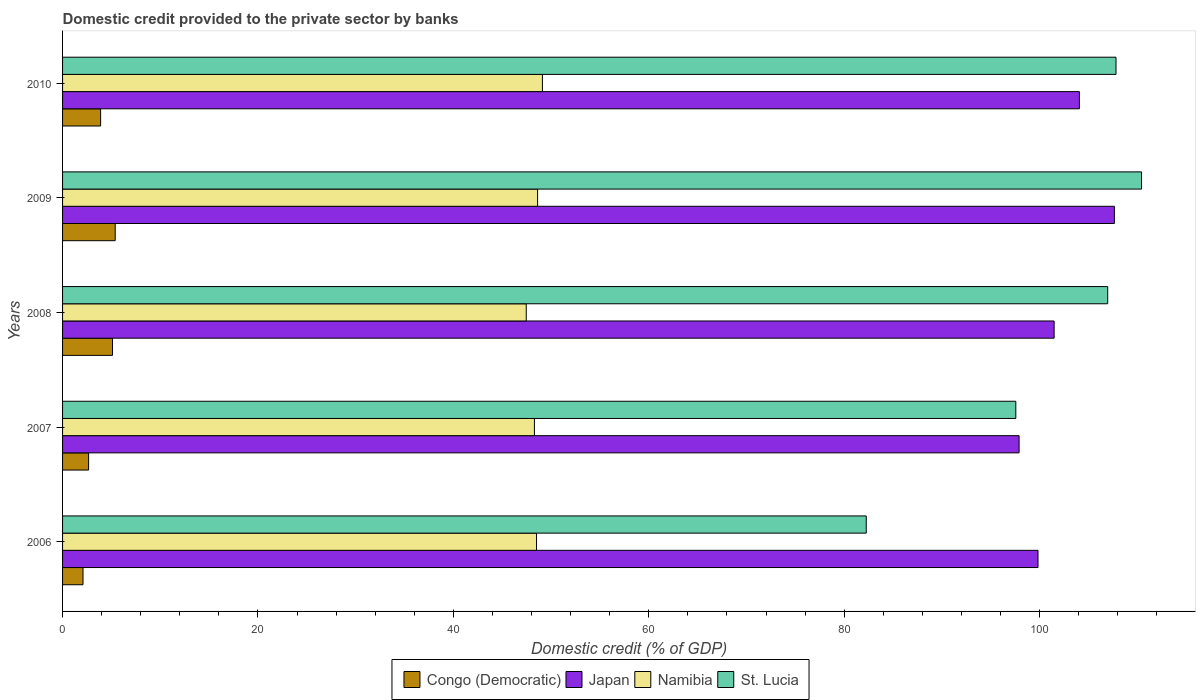How many different coloured bars are there?
Your answer should be very brief. 4. Are the number of bars per tick equal to the number of legend labels?
Ensure brevity in your answer.  Yes. Are the number of bars on each tick of the Y-axis equal?
Your answer should be very brief. Yes. How many bars are there on the 4th tick from the top?
Make the answer very short. 4. What is the label of the 2nd group of bars from the top?
Your response must be concise. 2009. In how many cases, is the number of bars for a given year not equal to the number of legend labels?
Provide a short and direct response. 0. What is the domestic credit provided to the private sector by banks in Japan in 2009?
Your answer should be compact. 107.65. Across all years, what is the maximum domestic credit provided to the private sector by banks in Japan?
Offer a very short reply. 107.65. Across all years, what is the minimum domestic credit provided to the private sector by banks in Namibia?
Your response must be concise. 47.46. In which year was the domestic credit provided to the private sector by banks in Japan minimum?
Your response must be concise. 2007. What is the total domestic credit provided to the private sector by banks in St. Lucia in the graph?
Provide a succinct answer. 505.04. What is the difference between the domestic credit provided to the private sector by banks in Congo (Democratic) in 2006 and that in 2010?
Your answer should be compact. -1.8. What is the difference between the domestic credit provided to the private sector by banks in Congo (Democratic) in 2009 and the domestic credit provided to the private sector by banks in Namibia in 2007?
Provide a succinct answer. -42.91. What is the average domestic credit provided to the private sector by banks in Japan per year?
Give a very brief answer. 102.19. In the year 2008, what is the difference between the domestic credit provided to the private sector by banks in St. Lucia and domestic credit provided to the private sector by banks in Japan?
Make the answer very short. 5.48. What is the ratio of the domestic credit provided to the private sector by banks in Congo (Democratic) in 2006 to that in 2009?
Your response must be concise. 0.39. Is the domestic credit provided to the private sector by banks in Congo (Democratic) in 2009 less than that in 2010?
Offer a very short reply. No. Is the difference between the domestic credit provided to the private sector by banks in St. Lucia in 2008 and 2009 greater than the difference between the domestic credit provided to the private sector by banks in Japan in 2008 and 2009?
Ensure brevity in your answer.  Yes. What is the difference between the highest and the second highest domestic credit provided to the private sector by banks in St. Lucia?
Ensure brevity in your answer.  2.61. What is the difference between the highest and the lowest domestic credit provided to the private sector by banks in Congo (Democratic)?
Keep it short and to the point. 3.3. What does the 2nd bar from the top in 2010 represents?
Ensure brevity in your answer.  Namibia. What does the 4th bar from the bottom in 2006 represents?
Offer a terse response. St. Lucia. How many bars are there?
Provide a succinct answer. 20. Are the values on the major ticks of X-axis written in scientific E-notation?
Offer a terse response. No. What is the title of the graph?
Your answer should be compact. Domestic credit provided to the private sector by banks. What is the label or title of the X-axis?
Provide a short and direct response. Domestic credit (% of GDP). What is the label or title of the Y-axis?
Keep it short and to the point. Years. What is the Domestic credit (% of GDP) in Congo (Democratic) in 2006?
Your answer should be compact. 2.09. What is the Domestic credit (% of GDP) of Japan in 2006?
Ensure brevity in your answer.  99.84. What is the Domestic credit (% of GDP) of Namibia in 2006?
Keep it short and to the point. 48.51. What is the Domestic credit (% of GDP) of St. Lucia in 2006?
Offer a terse response. 82.26. What is the Domestic credit (% of GDP) of Congo (Democratic) in 2007?
Provide a succinct answer. 2.67. What is the Domestic credit (% of GDP) in Japan in 2007?
Make the answer very short. 97.9. What is the Domestic credit (% of GDP) in Namibia in 2007?
Offer a terse response. 48.29. What is the Domestic credit (% of GDP) of St. Lucia in 2007?
Offer a very short reply. 97.56. What is the Domestic credit (% of GDP) in Congo (Democratic) in 2008?
Offer a very short reply. 5.11. What is the Domestic credit (% of GDP) of Japan in 2008?
Provide a short and direct response. 101.48. What is the Domestic credit (% of GDP) of Namibia in 2008?
Keep it short and to the point. 47.46. What is the Domestic credit (% of GDP) in St. Lucia in 2008?
Your response must be concise. 106.97. What is the Domestic credit (% of GDP) in Congo (Democratic) in 2009?
Give a very brief answer. 5.39. What is the Domestic credit (% of GDP) of Japan in 2009?
Make the answer very short. 107.65. What is the Domestic credit (% of GDP) in Namibia in 2009?
Ensure brevity in your answer.  48.62. What is the Domestic credit (% of GDP) in St. Lucia in 2009?
Offer a terse response. 110.43. What is the Domestic credit (% of GDP) of Congo (Democratic) in 2010?
Ensure brevity in your answer.  3.89. What is the Domestic credit (% of GDP) of Japan in 2010?
Your response must be concise. 104.07. What is the Domestic credit (% of GDP) of Namibia in 2010?
Offer a terse response. 49.11. What is the Domestic credit (% of GDP) of St. Lucia in 2010?
Offer a very short reply. 107.82. Across all years, what is the maximum Domestic credit (% of GDP) of Congo (Democratic)?
Provide a succinct answer. 5.39. Across all years, what is the maximum Domestic credit (% of GDP) of Japan?
Keep it short and to the point. 107.65. Across all years, what is the maximum Domestic credit (% of GDP) in Namibia?
Keep it short and to the point. 49.11. Across all years, what is the maximum Domestic credit (% of GDP) in St. Lucia?
Give a very brief answer. 110.43. Across all years, what is the minimum Domestic credit (% of GDP) in Congo (Democratic)?
Your response must be concise. 2.09. Across all years, what is the minimum Domestic credit (% of GDP) of Japan?
Keep it short and to the point. 97.9. Across all years, what is the minimum Domestic credit (% of GDP) of Namibia?
Provide a succinct answer. 47.46. Across all years, what is the minimum Domestic credit (% of GDP) of St. Lucia?
Provide a short and direct response. 82.26. What is the total Domestic credit (% of GDP) in Congo (Democratic) in the graph?
Your answer should be compact. 19.15. What is the total Domestic credit (% of GDP) in Japan in the graph?
Provide a short and direct response. 510.94. What is the total Domestic credit (% of GDP) of Namibia in the graph?
Ensure brevity in your answer.  241.99. What is the total Domestic credit (% of GDP) of St. Lucia in the graph?
Provide a short and direct response. 505.04. What is the difference between the Domestic credit (% of GDP) in Congo (Democratic) in 2006 and that in 2007?
Provide a short and direct response. -0.57. What is the difference between the Domestic credit (% of GDP) of Japan in 2006 and that in 2007?
Keep it short and to the point. 1.94. What is the difference between the Domestic credit (% of GDP) in Namibia in 2006 and that in 2007?
Your response must be concise. 0.22. What is the difference between the Domestic credit (% of GDP) of St. Lucia in 2006 and that in 2007?
Provide a short and direct response. -15.31. What is the difference between the Domestic credit (% of GDP) of Congo (Democratic) in 2006 and that in 2008?
Your answer should be compact. -3.02. What is the difference between the Domestic credit (% of GDP) of Japan in 2006 and that in 2008?
Provide a short and direct response. -1.65. What is the difference between the Domestic credit (% of GDP) of Namibia in 2006 and that in 2008?
Your answer should be very brief. 1.05. What is the difference between the Domestic credit (% of GDP) of St. Lucia in 2006 and that in 2008?
Your answer should be very brief. -24.71. What is the difference between the Domestic credit (% of GDP) in Congo (Democratic) in 2006 and that in 2009?
Provide a succinct answer. -3.3. What is the difference between the Domestic credit (% of GDP) of Japan in 2006 and that in 2009?
Make the answer very short. -7.82. What is the difference between the Domestic credit (% of GDP) in Namibia in 2006 and that in 2009?
Ensure brevity in your answer.  -0.11. What is the difference between the Domestic credit (% of GDP) in St. Lucia in 2006 and that in 2009?
Ensure brevity in your answer.  -28.18. What is the difference between the Domestic credit (% of GDP) of Congo (Democratic) in 2006 and that in 2010?
Offer a terse response. -1.8. What is the difference between the Domestic credit (% of GDP) in Japan in 2006 and that in 2010?
Your answer should be very brief. -4.24. What is the difference between the Domestic credit (% of GDP) of Namibia in 2006 and that in 2010?
Your answer should be compact. -0.6. What is the difference between the Domestic credit (% of GDP) of St. Lucia in 2006 and that in 2010?
Your answer should be very brief. -25.56. What is the difference between the Domestic credit (% of GDP) in Congo (Democratic) in 2007 and that in 2008?
Your response must be concise. -2.45. What is the difference between the Domestic credit (% of GDP) in Japan in 2007 and that in 2008?
Provide a succinct answer. -3.59. What is the difference between the Domestic credit (% of GDP) of Namibia in 2007 and that in 2008?
Provide a succinct answer. 0.84. What is the difference between the Domestic credit (% of GDP) in St. Lucia in 2007 and that in 2008?
Ensure brevity in your answer.  -9.41. What is the difference between the Domestic credit (% of GDP) in Congo (Democratic) in 2007 and that in 2009?
Give a very brief answer. -2.72. What is the difference between the Domestic credit (% of GDP) in Japan in 2007 and that in 2009?
Provide a succinct answer. -9.75. What is the difference between the Domestic credit (% of GDP) in Namibia in 2007 and that in 2009?
Provide a succinct answer. -0.32. What is the difference between the Domestic credit (% of GDP) of St. Lucia in 2007 and that in 2009?
Offer a very short reply. -12.87. What is the difference between the Domestic credit (% of GDP) of Congo (Democratic) in 2007 and that in 2010?
Your answer should be very brief. -1.23. What is the difference between the Domestic credit (% of GDP) in Japan in 2007 and that in 2010?
Provide a succinct answer. -6.17. What is the difference between the Domestic credit (% of GDP) in Namibia in 2007 and that in 2010?
Offer a terse response. -0.82. What is the difference between the Domestic credit (% of GDP) in St. Lucia in 2007 and that in 2010?
Provide a succinct answer. -10.26. What is the difference between the Domestic credit (% of GDP) of Congo (Democratic) in 2008 and that in 2009?
Your answer should be compact. -0.28. What is the difference between the Domestic credit (% of GDP) in Japan in 2008 and that in 2009?
Your response must be concise. -6.17. What is the difference between the Domestic credit (% of GDP) in Namibia in 2008 and that in 2009?
Give a very brief answer. -1.16. What is the difference between the Domestic credit (% of GDP) in St. Lucia in 2008 and that in 2009?
Give a very brief answer. -3.46. What is the difference between the Domestic credit (% of GDP) of Congo (Democratic) in 2008 and that in 2010?
Your answer should be very brief. 1.22. What is the difference between the Domestic credit (% of GDP) in Japan in 2008 and that in 2010?
Give a very brief answer. -2.59. What is the difference between the Domestic credit (% of GDP) of Namibia in 2008 and that in 2010?
Provide a succinct answer. -1.65. What is the difference between the Domestic credit (% of GDP) of St. Lucia in 2008 and that in 2010?
Make the answer very short. -0.85. What is the difference between the Domestic credit (% of GDP) of Congo (Democratic) in 2009 and that in 2010?
Ensure brevity in your answer.  1.49. What is the difference between the Domestic credit (% of GDP) of Japan in 2009 and that in 2010?
Offer a very short reply. 3.58. What is the difference between the Domestic credit (% of GDP) of Namibia in 2009 and that in 2010?
Keep it short and to the point. -0.49. What is the difference between the Domestic credit (% of GDP) in St. Lucia in 2009 and that in 2010?
Provide a succinct answer. 2.61. What is the difference between the Domestic credit (% of GDP) in Congo (Democratic) in 2006 and the Domestic credit (% of GDP) in Japan in 2007?
Make the answer very short. -95.81. What is the difference between the Domestic credit (% of GDP) in Congo (Democratic) in 2006 and the Domestic credit (% of GDP) in Namibia in 2007?
Keep it short and to the point. -46.2. What is the difference between the Domestic credit (% of GDP) in Congo (Democratic) in 2006 and the Domestic credit (% of GDP) in St. Lucia in 2007?
Offer a terse response. -95.47. What is the difference between the Domestic credit (% of GDP) of Japan in 2006 and the Domestic credit (% of GDP) of Namibia in 2007?
Offer a terse response. 51.54. What is the difference between the Domestic credit (% of GDP) of Japan in 2006 and the Domestic credit (% of GDP) of St. Lucia in 2007?
Offer a very short reply. 2.27. What is the difference between the Domestic credit (% of GDP) in Namibia in 2006 and the Domestic credit (% of GDP) in St. Lucia in 2007?
Ensure brevity in your answer.  -49.05. What is the difference between the Domestic credit (% of GDP) in Congo (Democratic) in 2006 and the Domestic credit (% of GDP) in Japan in 2008?
Provide a succinct answer. -99.39. What is the difference between the Domestic credit (% of GDP) of Congo (Democratic) in 2006 and the Domestic credit (% of GDP) of Namibia in 2008?
Your answer should be very brief. -45.36. What is the difference between the Domestic credit (% of GDP) of Congo (Democratic) in 2006 and the Domestic credit (% of GDP) of St. Lucia in 2008?
Provide a short and direct response. -104.88. What is the difference between the Domestic credit (% of GDP) in Japan in 2006 and the Domestic credit (% of GDP) in Namibia in 2008?
Keep it short and to the point. 52.38. What is the difference between the Domestic credit (% of GDP) in Japan in 2006 and the Domestic credit (% of GDP) in St. Lucia in 2008?
Keep it short and to the point. -7.13. What is the difference between the Domestic credit (% of GDP) in Namibia in 2006 and the Domestic credit (% of GDP) in St. Lucia in 2008?
Give a very brief answer. -58.46. What is the difference between the Domestic credit (% of GDP) of Congo (Democratic) in 2006 and the Domestic credit (% of GDP) of Japan in 2009?
Give a very brief answer. -105.56. What is the difference between the Domestic credit (% of GDP) in Congo (Democratic) in 2006 and the Domestic credit (% of GDP) in Namibia in 2009?
Provide a succinct answer. -46.53. What is the difference between the Domestic credit (% of GDP) in Congo (Democratic) in 2006 and the Domestic credit (% of GDP) in St. Lucia in 2009?
Your response must be concise. -108.34. What is the difference between the Domestic credit (% of GDP) of Japan in 2006 and the Domestic credit (% of GDP) of Namibia in 2009?
Ensure brevity in your answer.  51.22. What is the difference between the Domestic credit (% of GDP) in Japan in 2006 and the Domestic credit (% of GDP) in St. Lucia in 2009?
Your answer should be very brief. -10.6. What is the difference between the Domestic credit (% of GDP) of Namibia in 2006 and the Domestic credit (% of GDP) of St. Lucia in 2009?
Give a very brief answer. -61.92. What is the difference between the Domestic credit (% of GDP) of Congo (Democratic) in 2006 and the Domestic credit (% of GDP) of Japan in 2010?
Offer a very short reply. -101.98. What is the difference between the Domestic credit (% of GDP) in Congo (Democratic) in 2006 and the Domestic credit (% of GDP) in Namibia in 2010?
Offer a very short reply. -47.02. What is the difference between the Domestic credit (% of GDP) in Congo (Democratic) in 2006 and the Domestic credit (% of GDP) in St. Lucia in 2010?
Offer a very short reply. -105.73. What is the difference between the Domestic credit (% of GDP) of Japan in 2006 and the Domestic credit (% of GDP) of Namibia in 2010?
Offer a terse response. 50.72. What is the difference between the Domestic credit (% of GDP) of Japan in 2006 and the Domestic credit (% of GDP) of St. Lucia in 2010?
Make the answer very short. -7.98. What is the difference between the Domestic credit (% of GDP) in Namibia in 2006 and the Domestic credit (% of GDP) in St. Lucia in 2010?
Make the answer very short. -59.31. What is the difference between the Domestic credit (% of GDP) of Congo (Democratic) in 2007 and the Domestic credit (% of GDP) of Japan in 2008?
Offer a terse response. -98.82. What is the difference between the Domestic credit (% of GDP) in Congo (Democratic) in 2007 and the Domestic credit (% of GDP) in Namibia in 2008?
Offer a very short reply. -44.79. What is the difference between the Domestic credit (% of GDP) in Congo (Democratic) in 2007 and the Domestic credit (% of GDP) in St. Lucia in 2008?
Keep it short and to the point. -104.3. What is the difference between the Domestic credit (% of GDP) in Japan in 2007 and the Domestic credit (% of GDP) in Namibia in 2008?
Your answer should be very brief. 50.44. What is the difference between the Domestic credit (% of GDP) in Japan in 2007 and the Domestic credit (% of GDP) in St. Lucia in 2008?
Provide a succinct answer. -9.07. What is the difference between the Domestic credit (% of GDP) in Namibia in 2007 and the Domestic credit (% of GDP) in St. Lucia in 2008?
Your answer should be very brief. -58.67. What is the difference between the Domestic credit (% of GDP) of Congo (Democratic) in 2007 and the Domestic credit (% of GDP) of Japan in 2009?
Keep it short and to the point. -104.98. What is the difference between the Domestic credit (% of GDP) of Congo (Democratic) in 2007 and the Domestic credit (% of GDP) of Namibia in 2009?
Your answer should be very brief. -45.95. What is the difference between the Domestic credit (% of GDP) in Congo (Democratic) in 2007 and the Domestic credit (% of GDP) in St. Lucia in 2009?
Ensure brevity in your answer.  -107.77. What is the difference between the Domestic credit (% of GDP) in Japan in 2007 and the Domestic credit (% of GDP) in Namibia in 2009?
Give a very brief answer. 49.28. What is the difference between the Domestic credit (% of GDP) in Japan in 2007 and the Domestic credit (% of GDP) in St. Lucia in 2009?
Your answer should be very brief. -12.53. What is the difference between the Domestic credit (% of GDP) in Namibia in 2007 and the Domestic credit (% of GDP) in St. Lucia in 2009?
Your answer should be very brief. -62.14. What is the difference between the Domestic credit (% of GDP) of Congo (Democratic) in 2007 and the Domestic credit (% of GDP) of Japan in 2010?
Make the answer very short. -101.41. What is the difference between the Domestic credit (% of GDP) of Congo (Democratic) in 2007 and the Domestic credit (% of GDP) of Namibia in 2010?
Your answer should be compact. -46.45. What is the difference between the Domestic credit (% of GDP) in Congo (Democratic) in 2007 and the Domestic credit (% of GDP) in St. Lucia in 2010?
Provide a short and direct response. -105.15. What is the difference between the Domestic credit (% of GDP) in Japan in 2007 and the Domestic credit (% of GDP) in Namibia in 2010?
Offer a very short reply. 48.79. What is the difference between the Domestic credit (% of GDP) of Japan in 2007 and the Domestic credit (% of GDP) of St. Lucia in 2010?
Provide a short and direct response. -9.92. What is the difference between the Domestic credit (% of GDP) in Namibia in 2007 and the Domestic credit (% of GDP) in St. Lucia in 2010?
Give a very brief answer. -59.52. What is the difference between the Domestic credit (% of GDP) of Congo (Democratic) in 2008 and the Domestic credit (% of GDP) of Japan in 2009?
Give a very brief answer. -102.54. What is the difference between the Domestic credit (% of GDP) of Congo (Democratic) in 2008 and the Domestic credit (% of GDP) of Namibia in 2009?
Make the answer very short. -43.51. What is the difference between the Domestic credit (% of GDP) of Congo (Democratic) in 2008 and the Domestic credit (% of GDP) of St. Lucia in 2009?
Offer a terse response. -105.32. What is the difference between the Domestic credit (% of GDP) of Japan in 2008 and the Domestic credit (% of GDP) of Namibia in 2009?
Offer a very short reply. 52.87. What is the difference between the Domestic credit (% of GDP) of Japan in 2008 and the Domestic credit (% of GDP) of St. Lucia in 2009?
Ensure brevity in your answer.  -8.95. What is the difference between the Domestic credit (% of GDP) of Namibia in 2008 and the Domestic credit (% of GDP) of St. Lucia in 2009?
Offer a very short reply. -62.97. What is the difference between the Domestic credit (% of GDP) of Congo (Democratic) in 2008 and the Domestic credit (% of GDP) of Japan in 2010?
Ensure brevity in your answer.  -98.96. What is the difference between the Domestic credit (% of GDP) of Congo (Democratic) in 2008 and the Domestic credit (% of GDP) of Namibia in 2010?
Offer a terse response. -44. What is the difference between the Domestic credit (% of GDP) of Congo (Democratic) in 2008 and the Domestic credit (% of GDP) of St. Lucia in 2010?
Keep it short and to the point. -102.71. What is the difference between the Domestic credit (% of GDP) of Japan in 2008 and the Domestic credit (% of GDP) of Namibia in 2010?
Give a very brief answer. 52.37. What is the difference between the Domestic credit (% of GDP) of Japan in 2008 and the Domestic credit (% of GDP) of St. Lucia in 2010?
Offer a very short reply. -6.34. What is the difference between the Domestic credit (% of GDP) in Namibia in 2008 and the Domestic credit (% of GDP) in St. Lucia in 2010?
Offer a terse response. -60.36. What is the difference between the Domestic credit (% of GDP) in Congo (Democratic) in 2009 and the Domestic credit (% of GDP) in Japan in 2010?
Offer a very short reply. -98.68. What is the difference between the Domestic credit (% of GDP) in Congo (Democratic) in 2009 and the Domestic credit (% of GDP) in Namibia in 2010?
Your response must be concise. -43.72. What is the difference between the Domestic credit (% of GDP) in Congo (Democratic) in 2009 and the Domestic credit (% of GDP) in St. Lucia in 2010?
Make the answer very short. -102.43. What is the difference between the Domestic credit (% of GDP) in Japan in 2009 and the Domestic credit (% of GDP) in Namibia in 2010?
Give a very brief answer. 58.54. What is the difference between the Domestic credit (% of GDP) in Japan in 2009 and the Domestic credit (% of GDP) in St. Lucia in 2010?
Make the answer very short. -0.17. What is the difference between the Domestic credit (% of GDP) of Namibia in 2009 and the Domestic credit (% of GDP) of St. Lucia in 2010?
Give a very brief answer. -59.2. What is the average Domestic credit (% of GDP) of Congo (Democratic) per year?
Keep it short and to the point. 3.83. What is the average Domestic credit (% of GDP) of Japan per year?
Ensure brevity in your answer.  102.19. What is the average Domestic credit (% of GDP) in Namibia per year?
Offer a terse response. 48.4. What is the average Domestic credit (% of GDP) in St. Lucia per year?
Provide a short and direct response. 101.01. In the year 2006, what is the difference between the Domestic credit (% of GDP) in Congo (Democratic) and Domestic credit (% of GDP) in Japan?
Ensure brevity in your answer.  -97.74. In the year 2006, what is the difference between the Domestic credit (% of GDP) in Congo (Democratic) and Domestic credit (% of GDP) in Namibia?
Your answer should be very brief. -46.42. In the year 2006, what is the difference between the Domestic credit (% of GDP) of Congo (Democratic) and Domestic credit (% of GDP) of St. Lucia?
Keep it short and to the point. -80.16. In the year 2006, what is the difference between the Domestic credit (% of GDP) in Japan and Domestic credit (% of GDP) in Namibia?
Ensure brevity in your answer.  51.33. In the year 2006, what is the difference between the Domestic credit (% of GDP) of Japan and Domestic credit (% of GDP) of St. Lucia?
Ensure brevity in your answer.  17.58. In the year 2006, what is the difference between the Domestic credit (% of GDP) in Namibia and Domestic credit (% of GDP) in St. Lucia?
Your response must be concise. -33.75. In the year 2007, what is the difference between the Domestic credit (% of GDP) of Congo (Democratic) and Domestic credit (% of GDP) of Japan?
Provide a succinct answer. -95.23. In the year 2007, what is the difference between the Domestic credit (% of GDP) in Congo (Democratic) and Domestic credit (% of GDP) in Namibia?
Your response must be concise. -45.63. In the year 2007, what is the difference between the Domestic credit (% of GDP) in Congo (Democratic) and Domestic credit (% of GDP) in St. Lucia?
Your answer should be compact. -94.9. In the year 2007, what is the difference between the Domestic credit (% of GDP) of Japan and Domestic credit (% of GDP) of Namibia?
Your answer should be very brief. 49.6. In the year 2007, what is the difference between the Domestic credit (% of GDP) in Japan and Domestic credit (% of GDP) in St. Lucia?
Ensure brevity in your answer.  0.34. In the year 2007, what is the difference between the Domestic credit (% of GDP) of Namibia and Domestic credit (% of GDP) of St. Lucia?
Make the answer very short. -49.27. In the year 2008, what is the difference between the Domestic credit (% of GDP) of Congo (Democratic) and Domestic credit (% of GDP) of Japan?
Make the answer very short. -96.37. In the year 2008, what is the difference between the Domestic credit (% of GDP) in Congo (Democratic) and Domestic credit (% of GDP) in Namibia?
Your response must be concise. -42.35. In the year 2008, what is the difference between the Domestic credit (% of GDP) of Congo (Democratic) and Domestic credit (% of GDP) of St. Lucia?
Your answer should be compact. -101.86. In the year 2008, what is the difference between the Domestic credit (% of GDP) in Japan and Domestic credit (% of GDP) in Namibia?
Ensure brevity in your answer.  54.03. In the year 2008, what is the difference between the Domestic credit (% of GDP) in Japan and Domestic credit (% of GDP) in St. Lucia?
Offer a terse response. -5.48. In the year 2008, what is the difference between the Domestic credit (% of GDP) in Namibia and Domestic credit (% of GDP) in St. Lucia?
Keep it short and to the point. -59.51. In the year 2009, what is the difference between the Domestic credit (% of GDP) in Congo (Democratic) and Domestic credit (% of GDP) in Japan?
Provide a succinct answer. -102.26. In the year 2009, what is the difference between the Domestic credit (% of GDP) in Congo (Democratic) and Domestic credit (% of GDP) in Namibia?
Keep it short and to the point. -43.23. In the year 2009, what is the difference between the Domestic credit (% of GDP) of Congo (Democratic) and Domestic credit (% of GDP) of St. Lucia?
Your answer should be compact. -105.04. In the year 2009, what is the difference between the Domestic credit (% of GDP) in Japan and Domestic credit (% of GDP) in Namibia?
Your answer should be compact. 59.03. In the year 2009, what is the difference between the Domestic credit (% of GDP) of Japan and Domestic credit (% of GDP) of St. Lucia?
Offer a terse response. -2.78. In the year 2009, what is the difference between the Domestic credit (% of GDP) in Namibia and Domestic credit (% of GDP) in St. Lucia?
Your answer should be very brief. -61.81. In the year 2010, what is the difference between the Domestic credit (% of GDP) in Congo (Democratic) and Domestic credit (% of GDP) in Japan?
Offer a terse response. -100.18. In the year 2010, what is the difference between the Domestic credit (% of GDP) in Congo (Democratic) and Domestic credit (% of GDP) in Namibia?
Make the answer very short. -45.22. In the year 2010, what is the difference between the Domestic credit (% of GDP) of Congo (Democratic) and Domestic credit (% of GDP) of St. Lucia?
Offer a very short reply. -103.92. In the year 2010, what is the difference between the Domestic credit (% of GDP) of Japan and Domestic credit (% of GDP) of Namibia?
Offer a terse response. 54.96. In the year 2010, what is the difference between the Domestic credit (% of GDP) of Japan and Domestic credit (% of GDP) of St. Lucia?
Provide a short and direct response. -3.75. In the year 2010, what is the difference between the Domestic credit (% of GDP) of Namibia and Domestic credit (% of GDP) of St. Lucia?
Your answer should be very brief. -58.71. What is the ratio of the Domestic credit (% of GDP) of Congo (Democratic) in 2006 to that in 2007?
Your answer should be very brief. 0.78. What is the ratio of the Domestic credit (% of GDP) of Japan in 2006 to that in 2007?
Make the answer very short. 1.02. What is the ratio of the Domestic credit (% of GDP) of Namibia in 2006 to that in 2007?
Offer a very short reply. 1. What is the ratio of the Domestic credit (% of GDP) in St. Lucia in 2006 to that in 2007?
Your answer should be compact. 0.84. What is the ratio of the Domestic credit (% of GDP) in Congo (Democratic) in 2006 to that in 2008?
Your answer should be compact. 0.41. What is the ratio of the Domestic credit (% of GDP) of Japan in 2006 to that in 2008?
Provide a short and direct response. 0.98. What is the ratio of the Domestic credit (% of GDP) of Namibia in 2006 to that in 2008?
Give a very brief answer. 1.02. What is the ratio of the Domestic credit (% of GDP) in St. Lucia in 2006 to that in 2008?
Offer a terse response. 0.77. What is the ratio of the Domestic credit (% of GDP) of Congo (Democratic) in 2006 to that in 2009?
Your answer should be very brief. 0.39. What is the ratio of the Domestic credit (% of GDP) of Japan in 2006 to that in 2009?
Offer a terse response. 0.93. What is the ratio of the Domestic credit (% of GDP) in Namibia in 2006 to that in 2009?
Your answer should be very brief. 1. What is the ratio of the Domestic credit (% of GDP) in St. Lucia in 2006 to that in 2009?
Provide a succinct answer. 0.74. What is the ratio of the Domestic credit (% of GDP) of Congo (Democratic) in 2006 to that in 2010?
Offer a terse response. 0.54. What is the ratio of the Domestic credit (% of GDP) in Japan in 2006 to that in 2010?
Keep it short and to the point. 0.96. What is the ratio of the Domestic credit (% of GDP) of St. Lucia in 2006 to that in 2010?
Give a very brief answer. 0.76. What is the ratio of the Domestic credit (% of GDP) of Congo (Democratic) in 2007 to that in 2008?
Offer a very short reply. 0.52. What is the ratio of the Domestic credit (% of GDP) in Japan in 2007 to that in 2008?
Keep it short and to the point. 0.96. What is the ratio of the Domestic credit (% of GDP) in Namibia in 2007 to that in 2008?
Your response must be concise. 1.02. What is the ratio of the Domestic credit (% of GDP) of St. Lucia in 2007 to that in 2008?
Offer a terse response. 0.91. What is the ratio of the Domestic credit (% of GDP) of Congo (Democratic) in 2007 to that in 2009?
Offer a very short reply. 0.49. What is the ratio of the Domestic credit (% of GDP) in Japan in 2007 to that in 2009?
Your answer should be very brief. 0.91. What is the ratio of the Domestic credit (% of GDP) of St. Lucia in 2007 to that in 2009?
Your response must be concise. 0.88. What is the ratio of the Domestic credit (% of GDP) of Congo (Democratic) in 2007 to that in 2010?
Offer a terse response. 0.68. What is the ratio of the Domestic credit (% of GDP) of Japan in 2007 to that in 2010?
Give a very brief answer. 0.94. What is the ratio of the Domestic credit (% of GDP) in Namibia in 2007 to that in 2010?
Make the answer very short. 0.98. What is the ratio of the Domestic credit (% of GDP) in St. Lucia in 2007 to that in 2010?
Your answer should be very brief. 0.9. What is the ratio of the Domestic credit (% of GDP) in Congo (Democratic) in 2008 to that in 2009?
Your response must be concise. 0.95. What is the ratio of the Domestic credit (% of GDP) of Japan in 2008 to that in 2009?
Offer a very short reply. 0.94. What is the ratio of the Domestic credit (% of GDP) of Namibia in 2008 to that in 2009?
Make the answer very short. 0.98. What is the ratio of the Domestic credit (% of GDP) in St. Lucia in 2008 to that in 2009?
Ensure brevity in your answer.  0.97. What is the ratio of the Domestic credit (% of GDP) of Congo (Democratic) in 2008 to that in 2010?
Offer a very short reply. 1.31. What is the ratio of the Domestic credit (% of GDP) in Japan in 2008 to that in 2010?
Keep it short and to the point. 0.98. What is the ratio of the Domestic credit (% of GDP) of Namibia in 2008 to that in 2010?
Make the answer very short. 0.97. What is the ratio of the Domestic credit (% of GDP) in St. Lucia in 2008 to that in 2010?
Offer a very short reply. 0.99. What is the ratio of the Domestic credit (% of GDP) in Congo (Democratic) in 2009 to that in 2010?
Offer a very short reply. 1.38. What is the ratio of the Domestic credit (% of GDP) of Japan in 2009 to that in 2010?
Your response must be concise. 1.03. What is the ratio of the Domestic credit (% of GDP) in St. Lucia in 2009 to that in 2010?
Provide a succinct answer. 1.02. What is the difference between the highest and the second highest Domestic credit (% of GDP) in Congo (Democratic)?
Make the answer very short. 0.28. What is the difference between the highest and the second highest Domestic credit (% of GDP) of Japan?
Provide a short and direct response. 3.58. What is the difference between the highest and the second highest Domestic credit (% of GDP) in Namibia?
Your answer should be compact. 0.49. What is the difference between the highest and the second highest Domestic credit (% of GDP) in St. Lucia?
Provide a succinct answer. 2.61. What is the difference between the highest and the lowest Domestic credit (% of GDP) in Congo (Democratic)?
Your answer should be very brief. 3.3. What is the difference between the highest and the lowest Domestic credit (% of GDP) of Japan?
Your answer should be very brief. 9.75. What is the difference between the highest and the lowest Domestic credit (% of GDP) in Namibia?
Offer a terse response. 1.65. What is the difference between the highest and the lowest Domestic credit (% of GDP) in St. Lucia?
Provide a short and direct response. 28.18. 